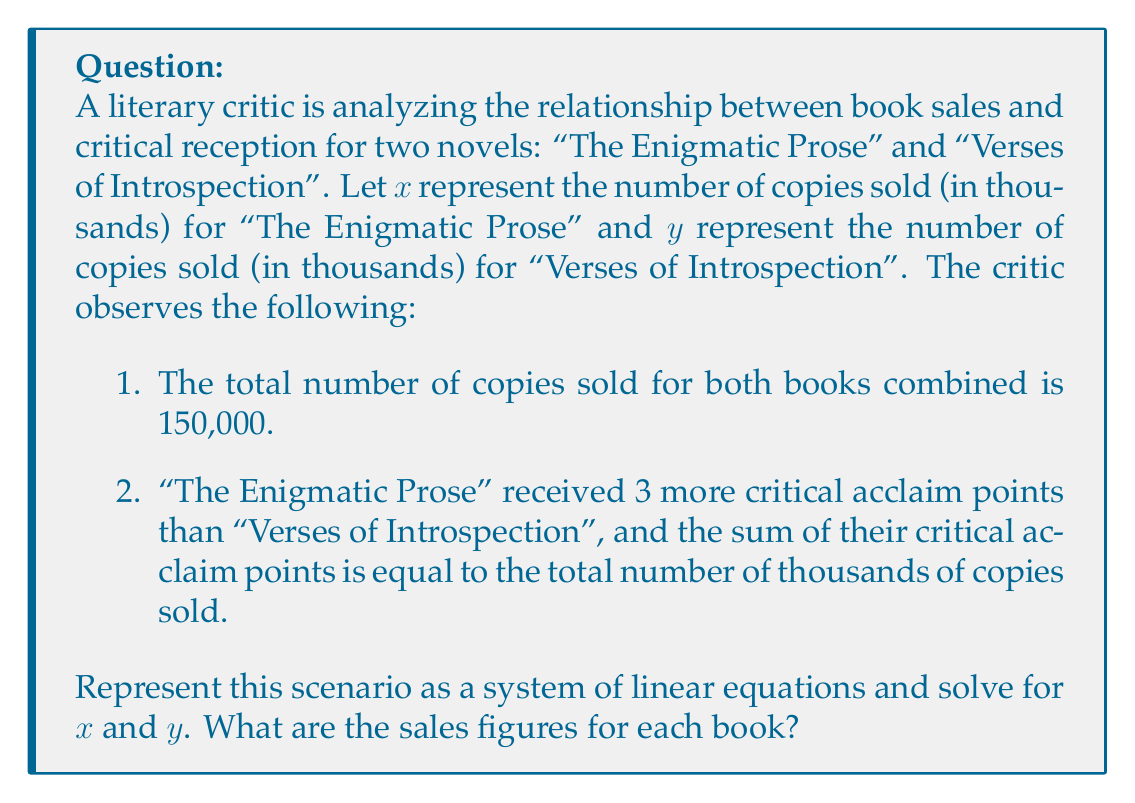Can you answer this question? Let's approach this step-by-step:

1) First, let's translate the given information into a system of linear equations:

   Equation 1 (total sales): $x + y = 150$ (since $x$ and $y$ are in thousands)
   
   Equation 2 (critical acclaim): $(x + 3) + y = x + y$ (the sum of critical points equals total sales in thousands)

2) Let's simplify Equation 2:
   $x + 3 + y = x + y$
   $x + y + 3 = x + y$
   $3 = 0$

   This is always true, so Equation 2 doesn't give us any new information.

3) We need another equation. We can derive one from the given information:
   "The Enigmatic Prose" received 3 more critical acclaim points than "Verses of Introspection"
   This means: $x + 3 = y$

4) Now we have a solvable system of linear equations:
   Equation 1: $x + y = 150$
   Equation 3: $x + 3 = y$

5) Let's solve this system by substitution. From Equation 3:
   $y = x + 3$

6) Substitute this into Equation 1:
   $x + (x + 3) = 150$
   $2x + 3 = 150$
   $2x = 147$
   $x = 73.5$

7) Now we can find $y$ by substituting $x$ back into Equation 3:
   $y = 73.5 + 3 = 76.5$

Therefore, "The Enigmatic Prose" sold 73,500 copies and "Verses of Introspection" sold 76,500 copies.
Answer: "The Enigmatic Prose": 73,500 copies; "Verses of Introspection": 76,500 copies 